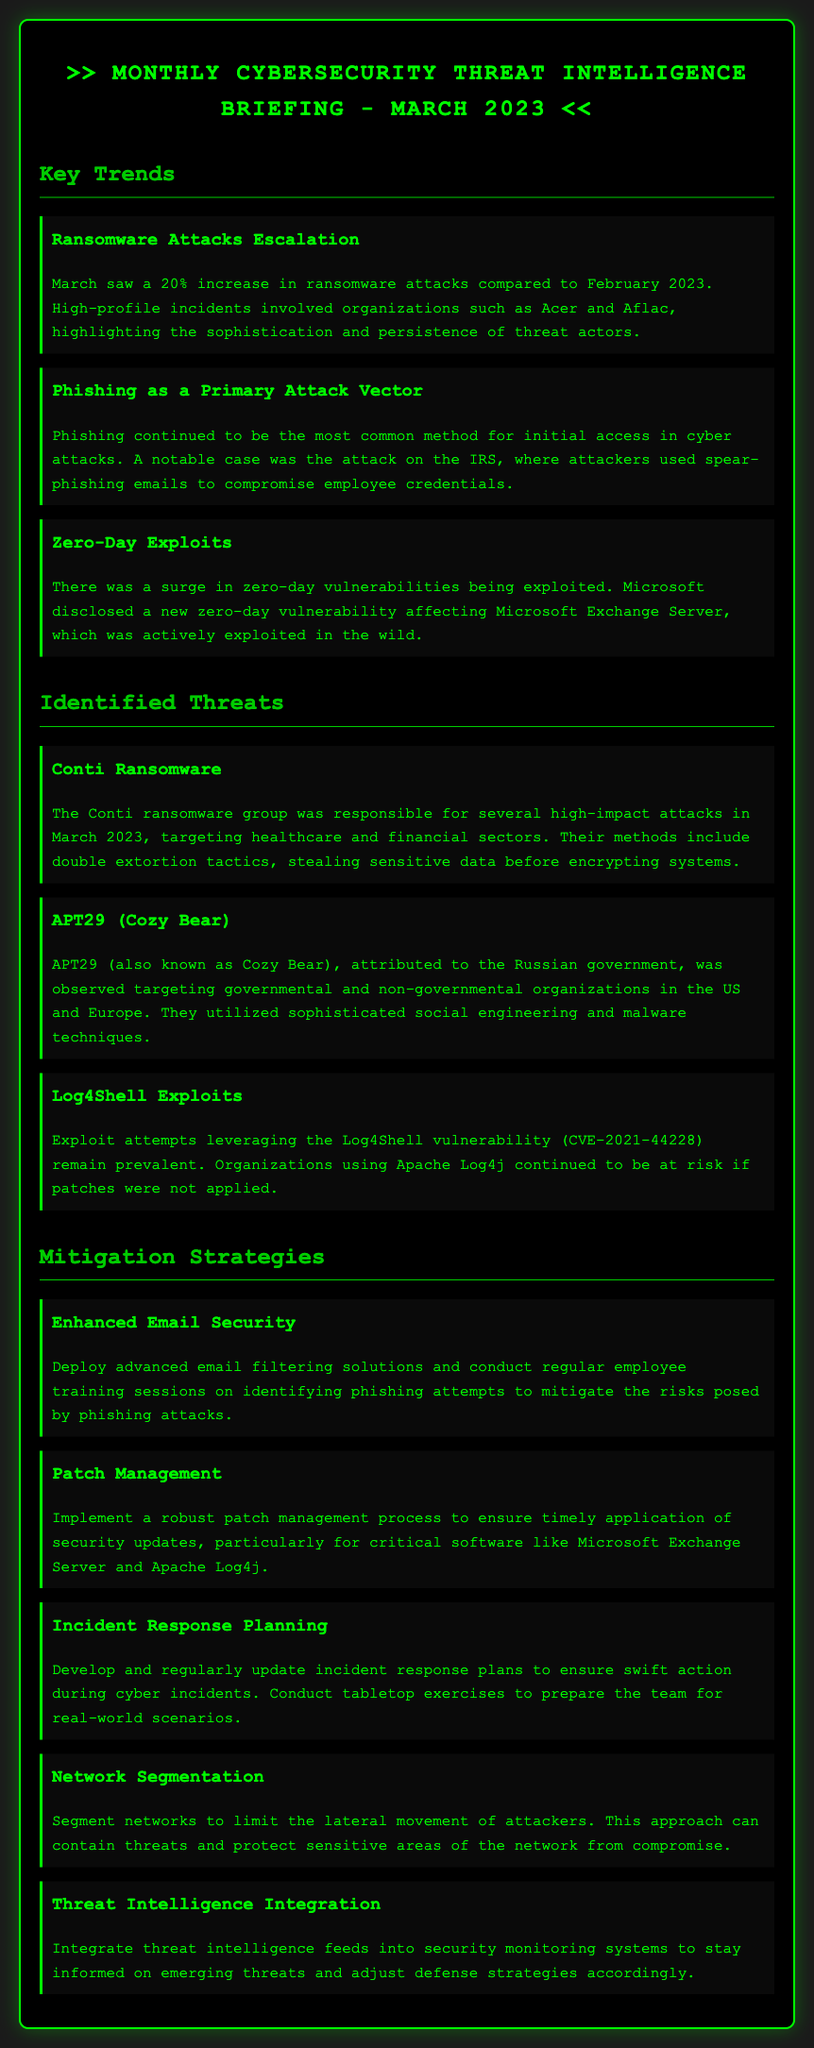What was the percentage increase in ransomware attacks from February to March 2023? The document states that there was a 20% increase in ransomware attacks compared to February 2023.
Answer: 20% Which group was responsible for several high-impact attacks targeting healthcare and financial sectors in March 2023? The document identifies the Conti ransomware group as responsible for several high-impact attacks.
Answer: Conti What attack method was highlighted in the incident involving the IRS? The document specifies that phishing was the attack method used in the IRS incident.
Answer: Phishing What vulnerability was actively exploited in the wild, affecting Microsoft Exchange Server? The document states that a new zero-day vulnerability affecting Microsoft Exchange Server was exploited.
Answer: Zero-day vulnerability Which mitigation strategy involves deploying advanced filtering solutions? The document mentions that enhanced email security involves advanced email filtering solutions.
Answer: Enhanced Email Security In which sectors did APT29 (Cozy Bear) primarily focus its attacks? The document states that APT29 targeted governmental and non-governmental organizations.
Answer: Governmental and non-governmental organizations What was one of the suggested strategies to limit the lateral movement of attackers? The document suggests network segmentation as a strategy to limit lateral movement of attackers.
Answer: Network Segmentation What should organizations implement to ensure timely application of updates? The document recommends implementing a robust patch management process.
Answer: Patch Management Which tactic did Conti ransomware group use alongside encrypting systems? The document mentions double extortion tactics, which involves stealing sensitive data before encrypting systems.
Answer: Double extortion tactics 